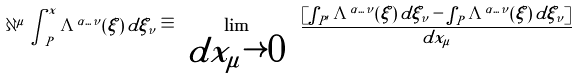<formula> <loc_0><loc_0><loc_500><loc_500>\partial ^ { \mu } \int _ { P } ^ { x } \Lambda ^ { \alpha \dots \nu } ( \xi ) \, d \xi _ { \nu } \equiv \lim _ { \begin{array} { l } d x _ { \mu } \rightarrow 0 \end{array} } \, \frac { \left [ \int _ { P ^ { \prime } } \Lambda ^ { \alpha \dots \nu } ( \xi ) \, d \xi _ { \nu } - \int _ { P } \Lambda ^ { \alpha \dots \nu } ( \xi ) \, d \xi _ { \nu } \right ] } { d x _ { \mu } }</formula> 